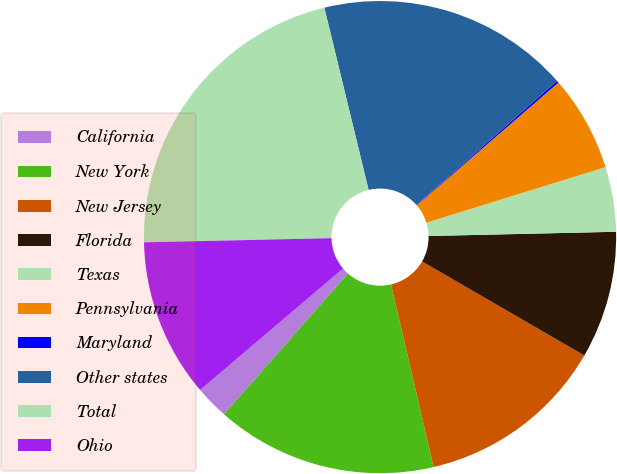<chart> <loc_0><loc_0><loc_500><loc_500><pie_chart><fcel>California<fcel>New York<fcel>New Jersey<fcel>Florida<fcel>Texas<fcel>Pennsylvania<fcel>Maryland<fcel>Other states<fcel>Total<fcel>Ohio<nl><fcel>2.29%<fcel>15.14%<fcel>13.0%<fcel>8.72%<fcel>4.43%<fcel>6.57%<fcel>0.15%<fcel>17.28%<fcel>21.56%<fcel>10.86%<nl></chart> 